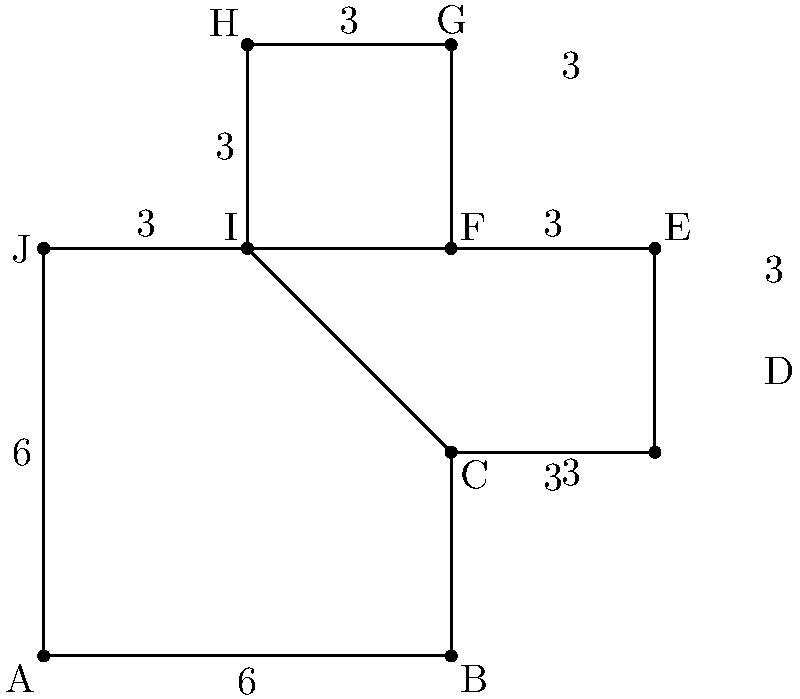As a preacher, you're tasked with calculating the area of your church's unique cross-shaped floor plan. The floor plan is represented in a coordinate system where each unit equals 10 feet. The dimensions are shown in the diagram above. What is the total area of the church floor in square feet? Let's approach this step-by-step:

1) The church floor plan can be divided into a large rectangle and two smaller rectangles.

2) The large rectangle:
   Width = 6 units
   Height = 9 units
   Area = $6 \times 9 = 54$ square units

3) Each smaller rectangle:
   Width = 3 units
   Height = 3 units
   Area of one = $3 \times 3 = 9$ square units
   Area of both = $9 \times 2 = 18$ square units

4) Total area in square units:
   $54 + 18 = 72$ square units

5) Convert to square feet:
   Each unit is 10 feet, so each square unit is 100 square feet.
   $72 \times 100 = 7200$ square feet

Therefore, the total area of the church floor is 7200 square feet.
Answer: 7200 square feet 